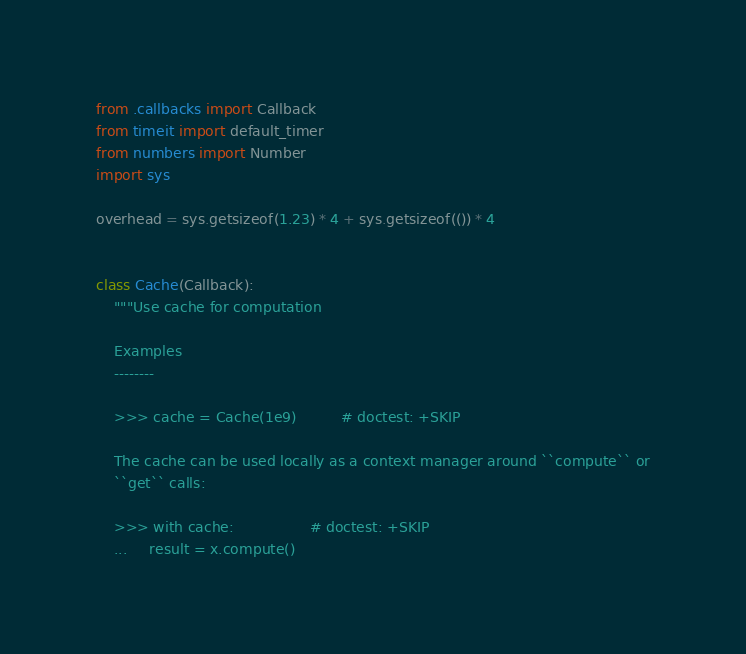<code> <loc_0><loc_0><loc_500><loc_500><_Python_>from .callbacks import Callback
from timeit import default_timer
from numbers import Number
import sys

overhead = sys.getsizeof(1.23) * 4 + sys.getsizeof(()) * 4


class Cache(Callback):
    """Use cache for computation

    Examples
    --------

    >>> cache = Cache(1e9)          # doctest: +SKIP

    The cache can be used locally as a context manager around ``compute`` or
    ``get`` calls:

    >>> with cache:                 # doctest: +SKIP
    ...     result = x.compute()
</code> 